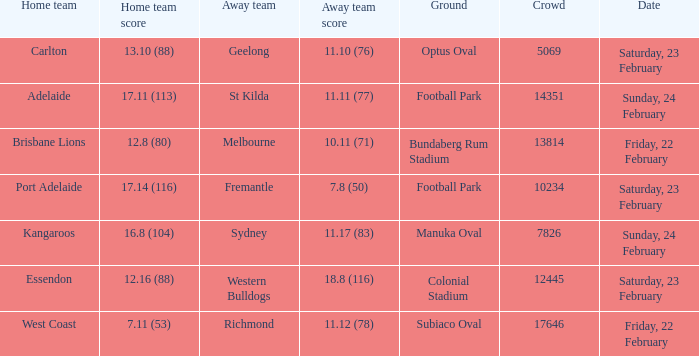What score did the away team receive against home team Port Adelaide? 7.8 (50). 